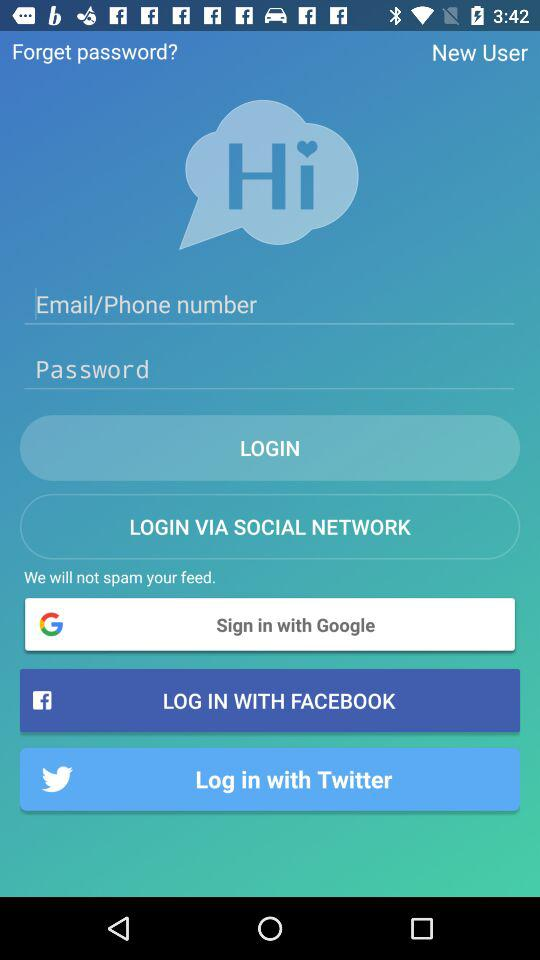Through what application can we log in? You can log in with "Google", "FACEBOOK" and "Twitter". 